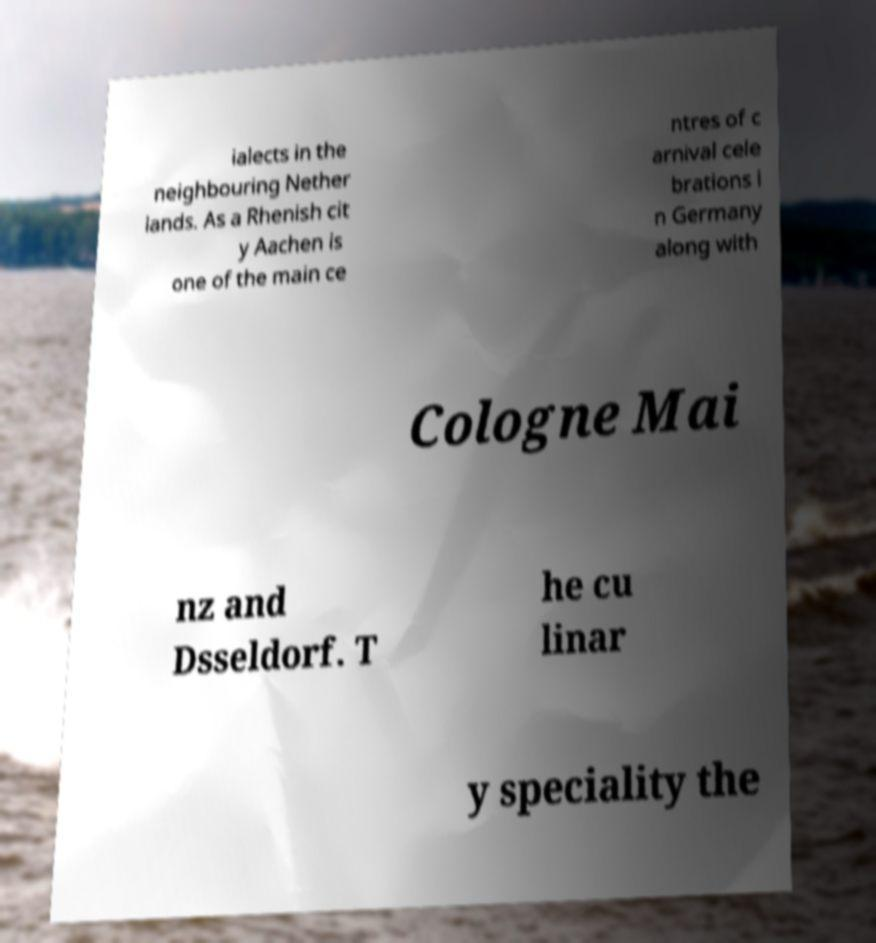Could you assist in decoding the text presented in this image and type it out clearly? ialects in the neighbouring Nether lands. As a Rhenish cit y Aachen is one of the main ce ntres of c arnival cele brations i n Germany along with Cologne Mai nz and Dsseldorf. T he cu linar y speciality the 